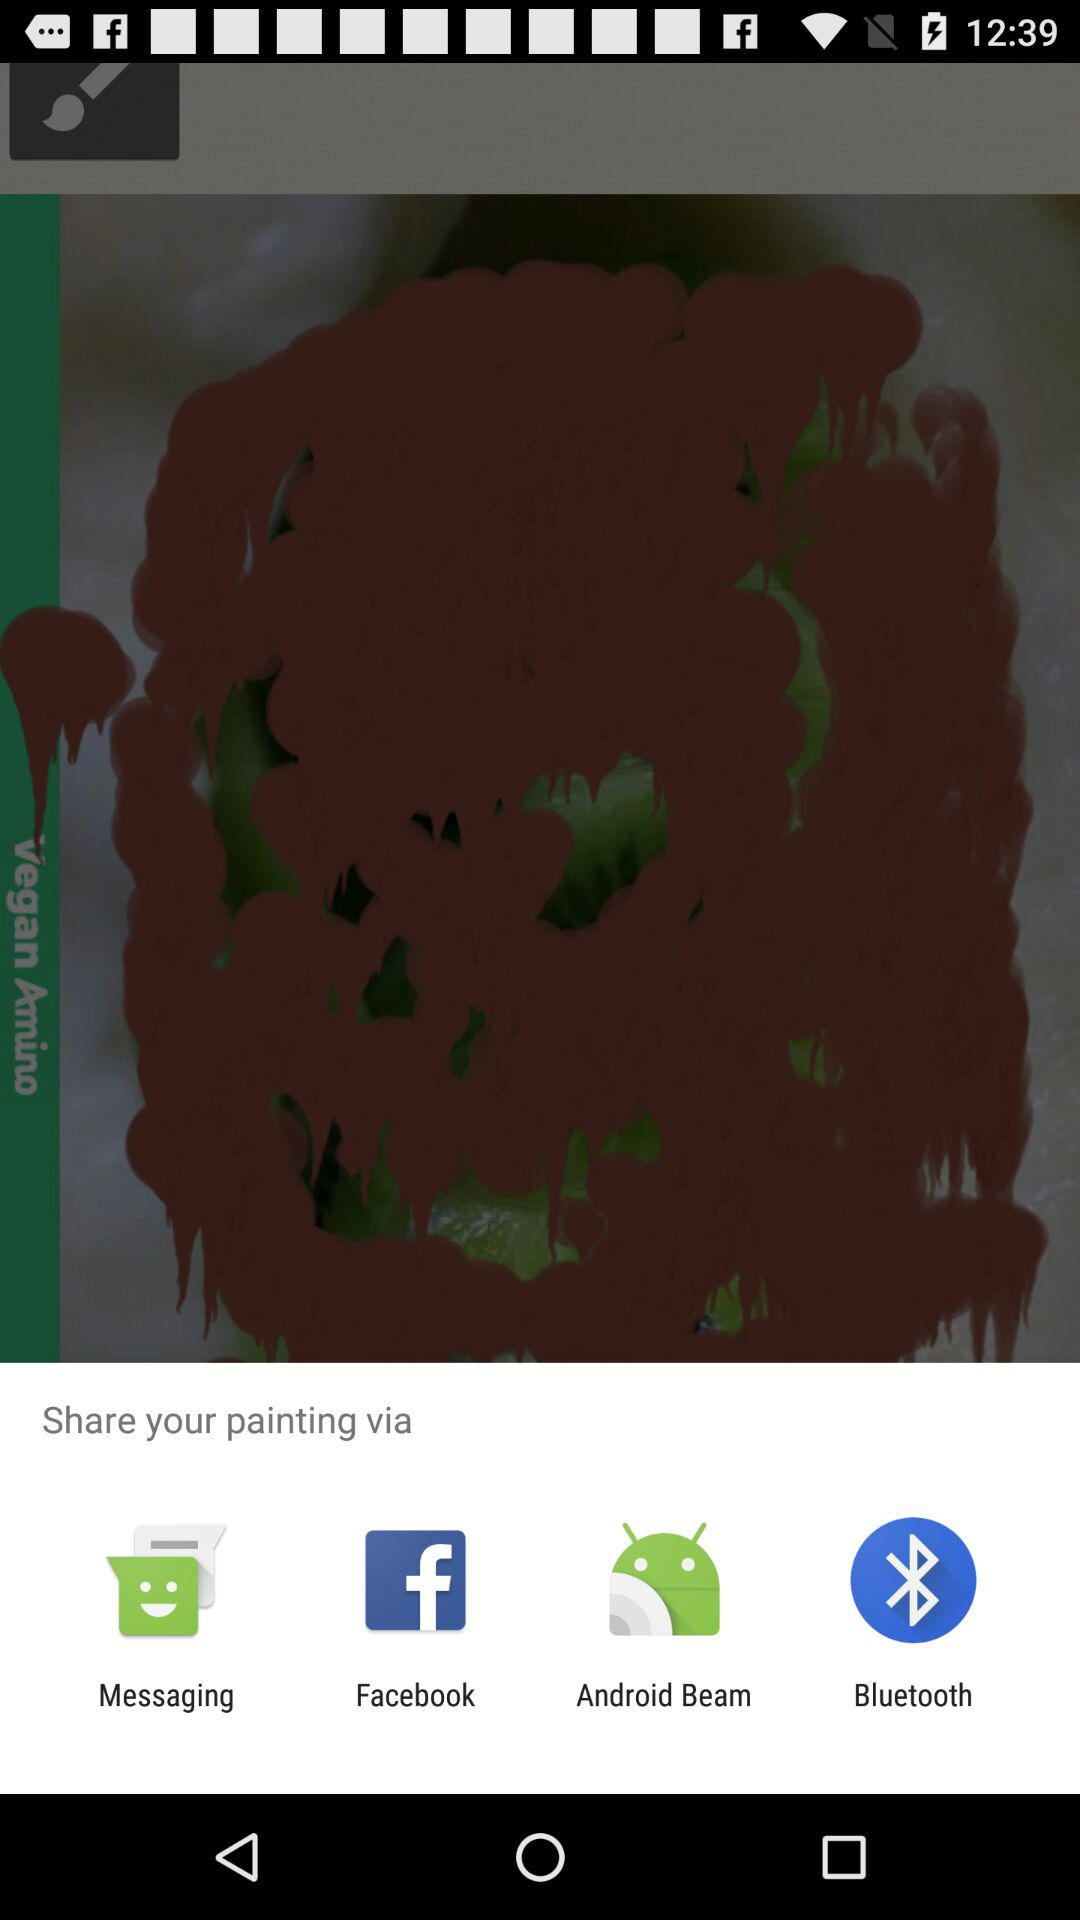What options are available for sharing? The options available are "Messaging", "Facebook", "Android Beam" and "Bluetooth". 